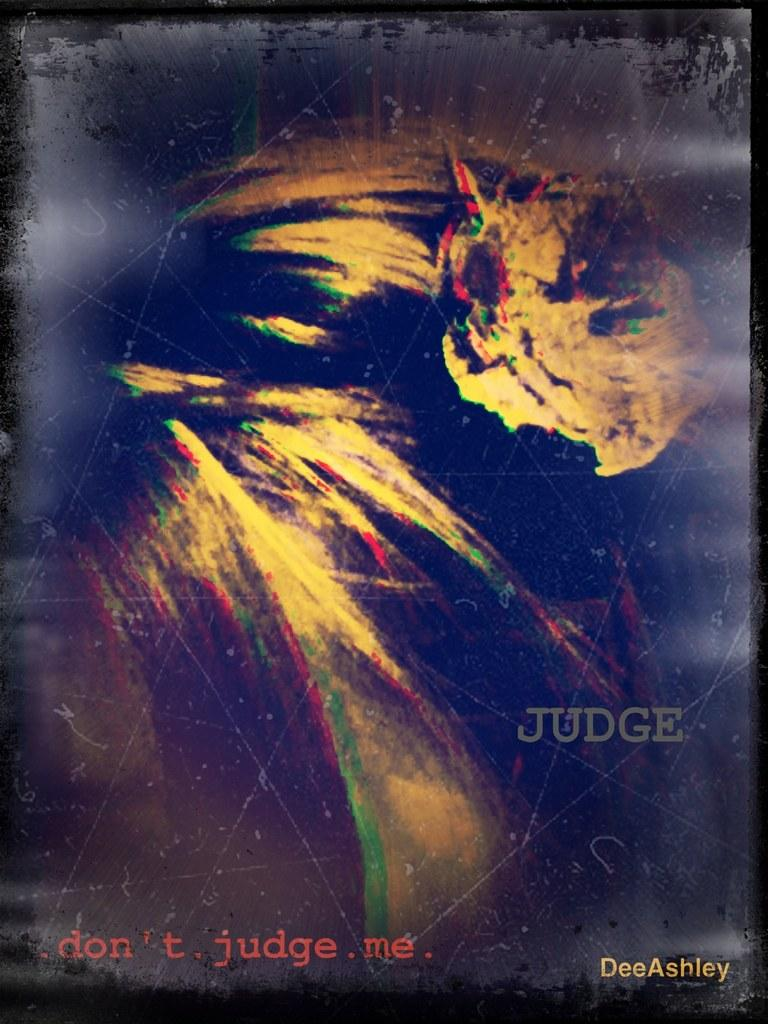Provide a one-sentence caption for the provided image. a photo of of earth that says dont judge me. 